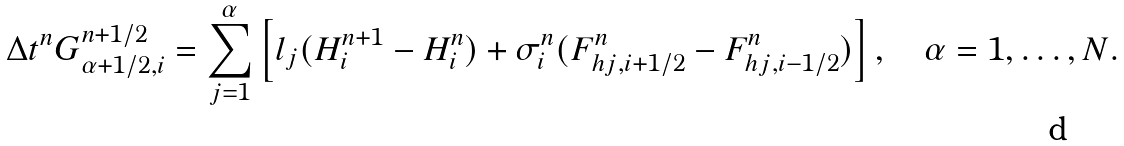<formula> <loc_0><loc_0><loc_500><loc_500>\Delta t ^ { n } G _ { \alpha + 1 / 2 , i } ^ { n + 1 / 2 } = \sum _ { j = 1 } ^ { \alpha } \left [ l _ { j } ( H _ { i } ^ { n + 1 } - H _ { i } ^ { n } ) + \sigma ^ { n } _ { i } ( F _ { h j , i + 1 / 2 } ^ { n } - F _ { h j , i - 1 / 2 } ^ { n } ) \right ] , \quad \alpha = 1 , \dots , N .</formula> 